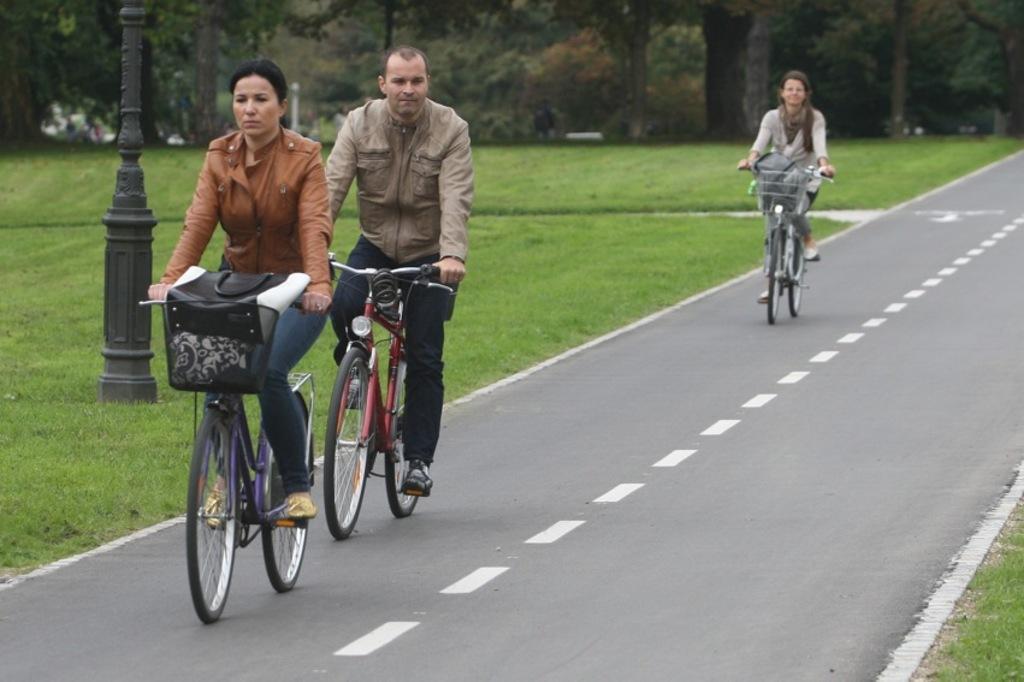In one or two sentences, can you explain what this image depicts? Here in this picture we can see two ladies and one man is riding bicycle on the road. On the right side there is a grass. On the left side there is a grass and in background we can see some trees. And left side there is a pole. 